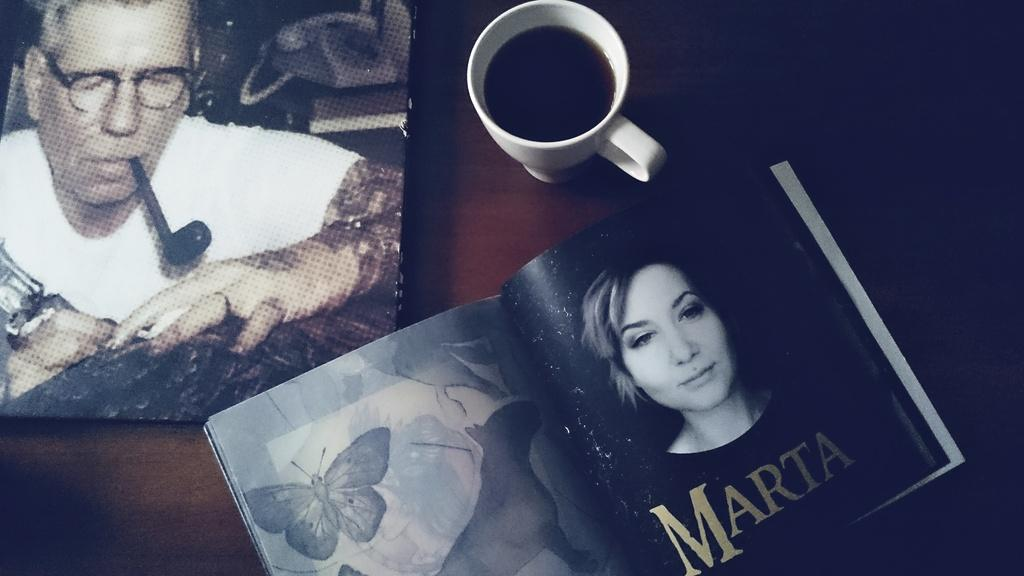What object is located on the left side of the image? There is a book on the left side of the image. What can be found inside the book? The book contains an image of a man and a picture of a woman. What other object is visible in the image? There is a coffee mug in the image. What type of account does the book provide about the cream in the image? There is no mention of cream in the image, and the book does not provide any account about it. 